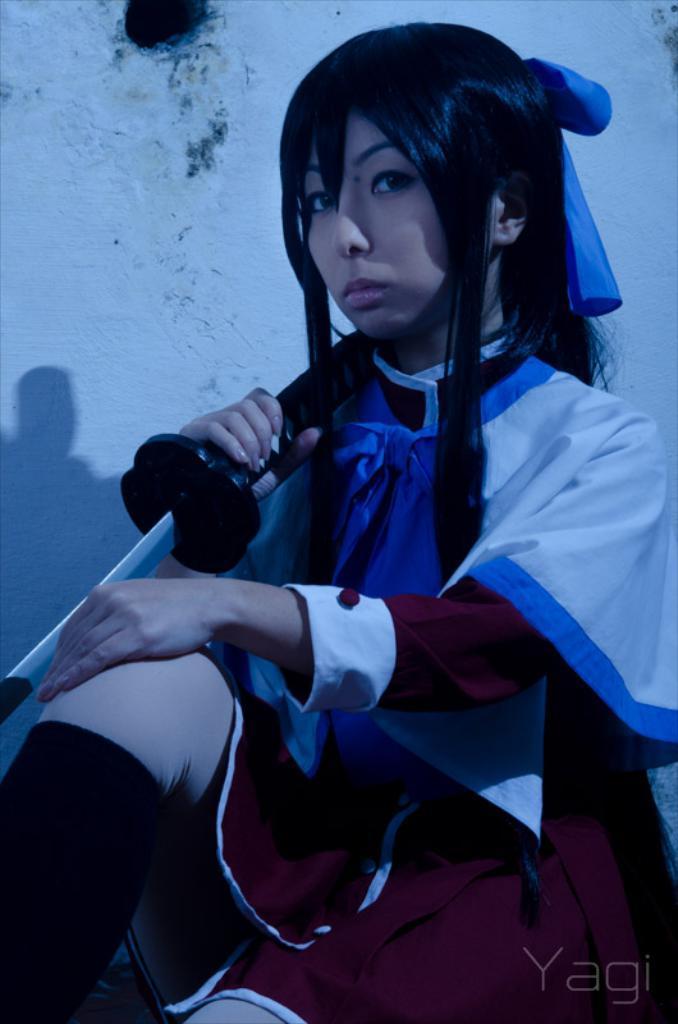In one or two sentences, can you explain what this image depicts? In this picture I can see there is a woman sitting and she is wearing a dress and holding a sword. There is a wall in the backdrop. 